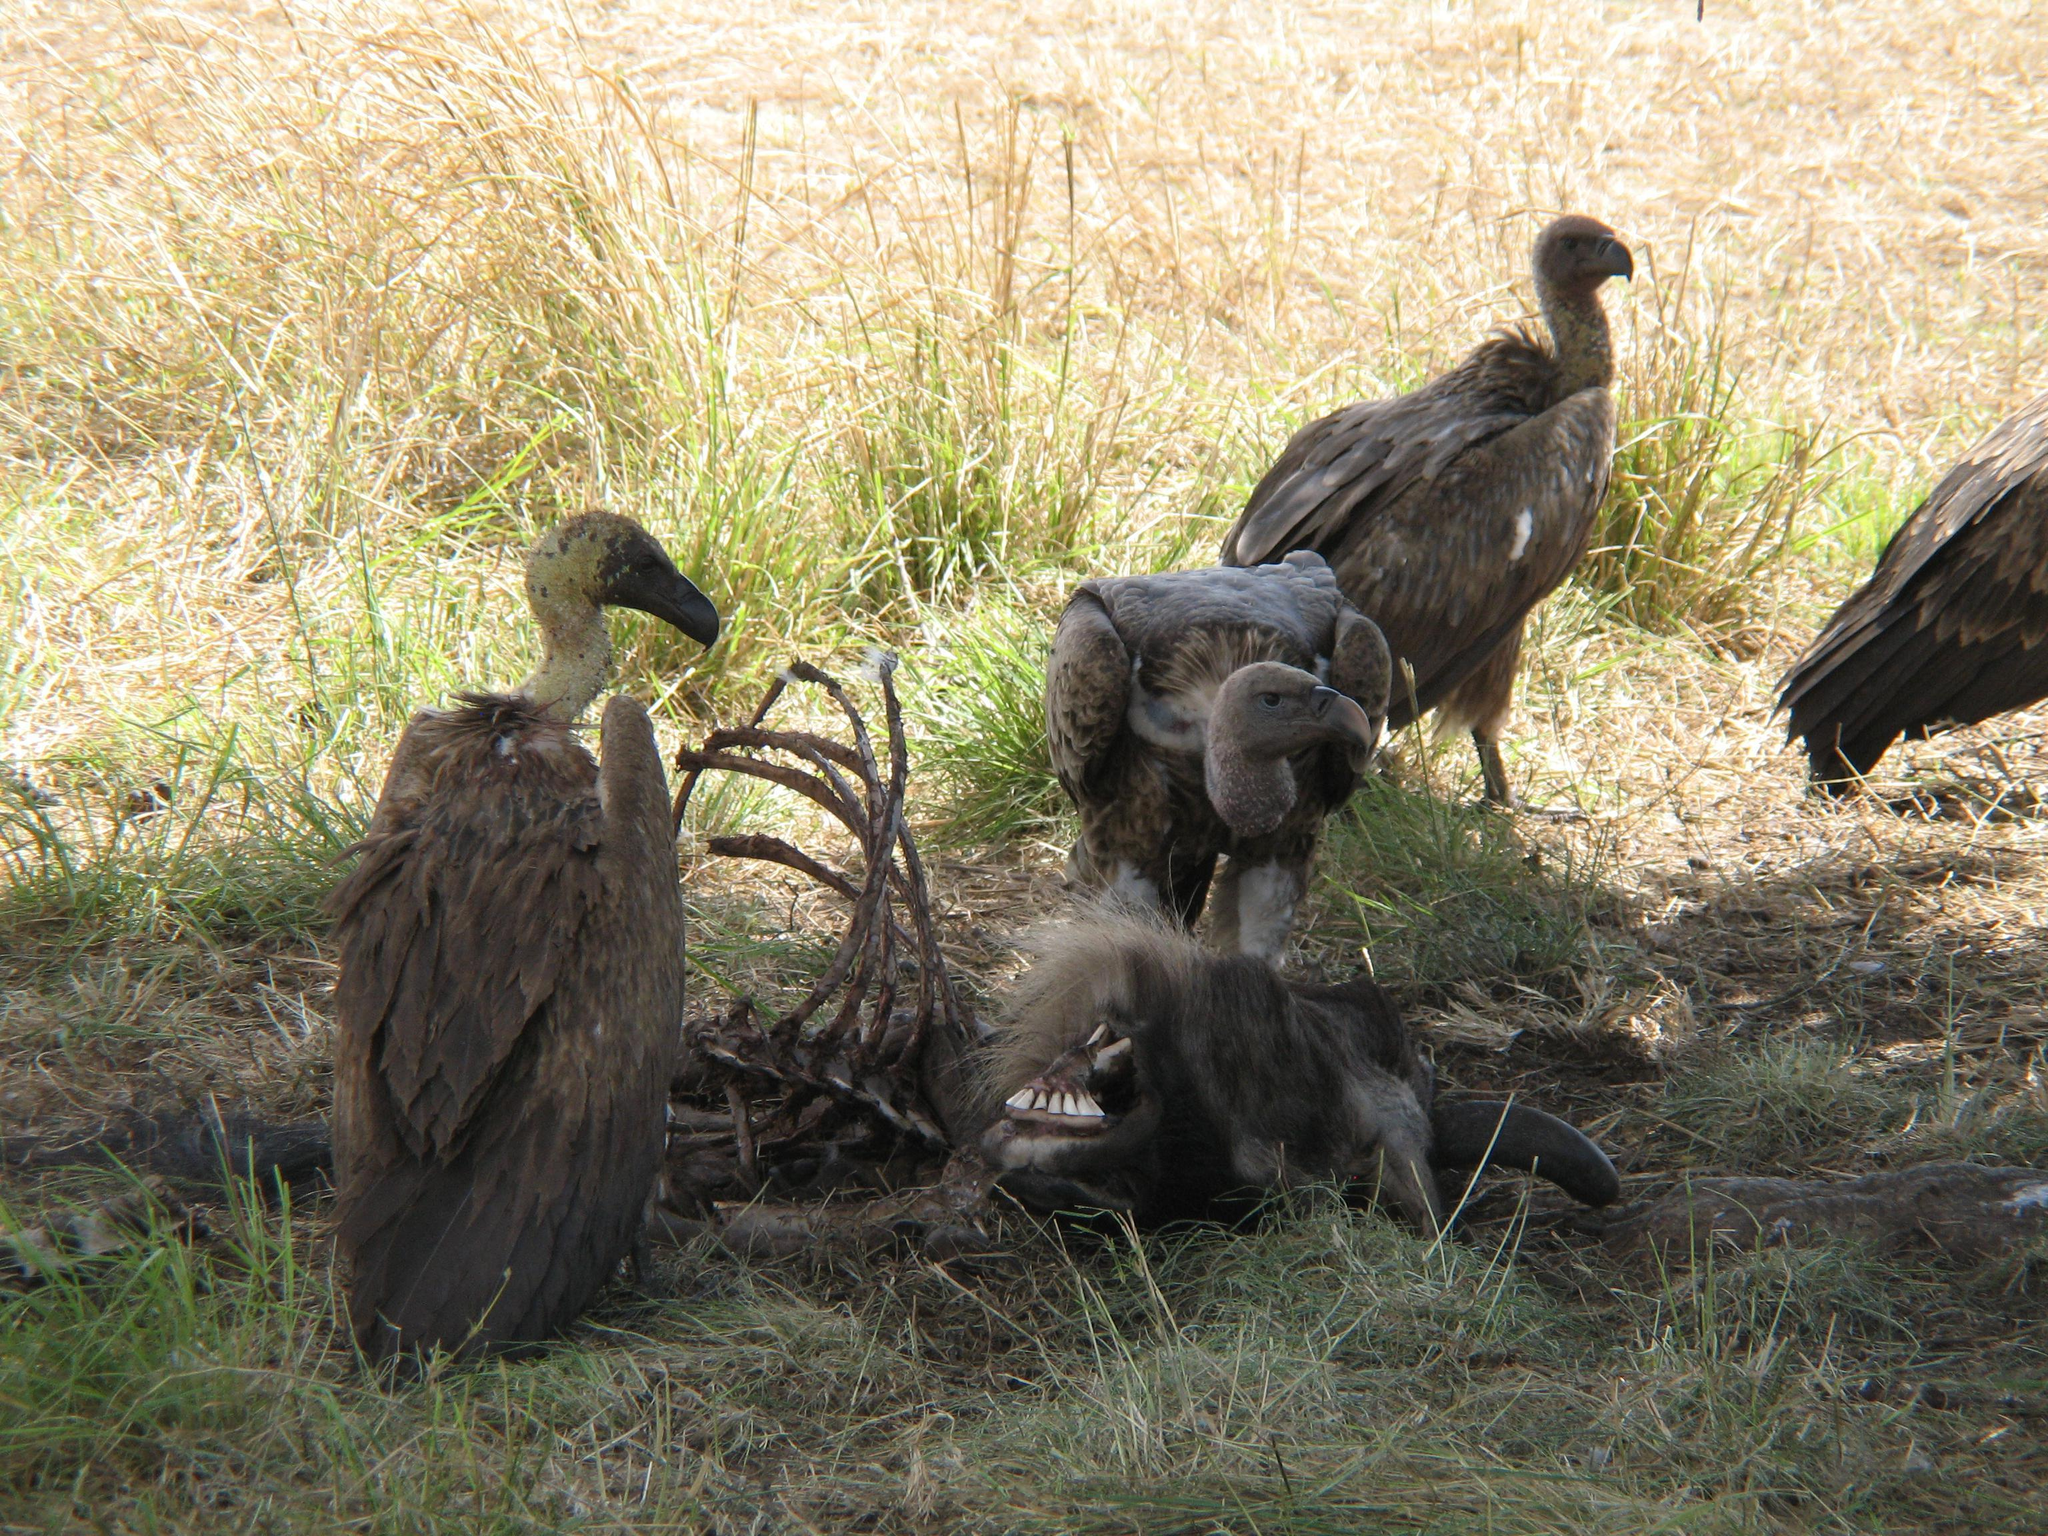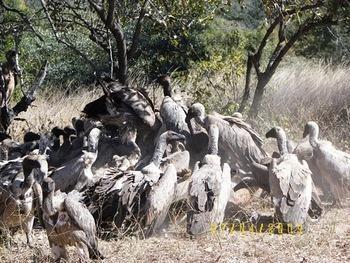The first image is the image on the left, the second image is the image on the right. For the images shown, is this caption "There is no more than three birds." true? Answer yes or no. No. 